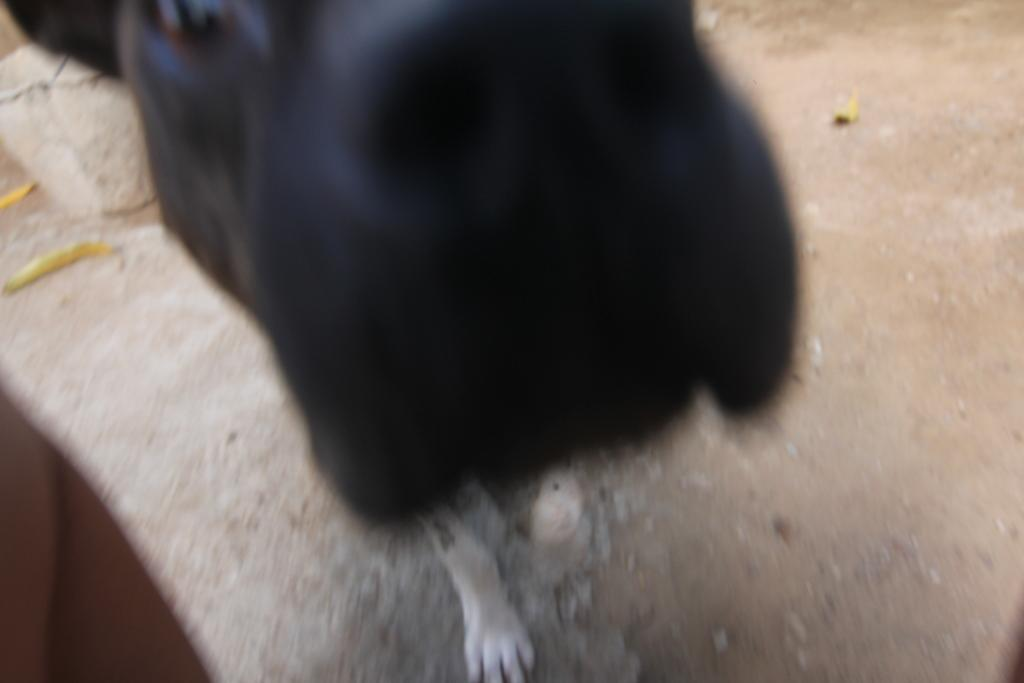What type of animal is present in the image? There is a dog in the image. What is the dog doing in the image? The dog is standing on the ground. What type of art is being displayed at the event with the giants in the image? There is no event or giants present in the image; it only features a dog standing on the ground. 